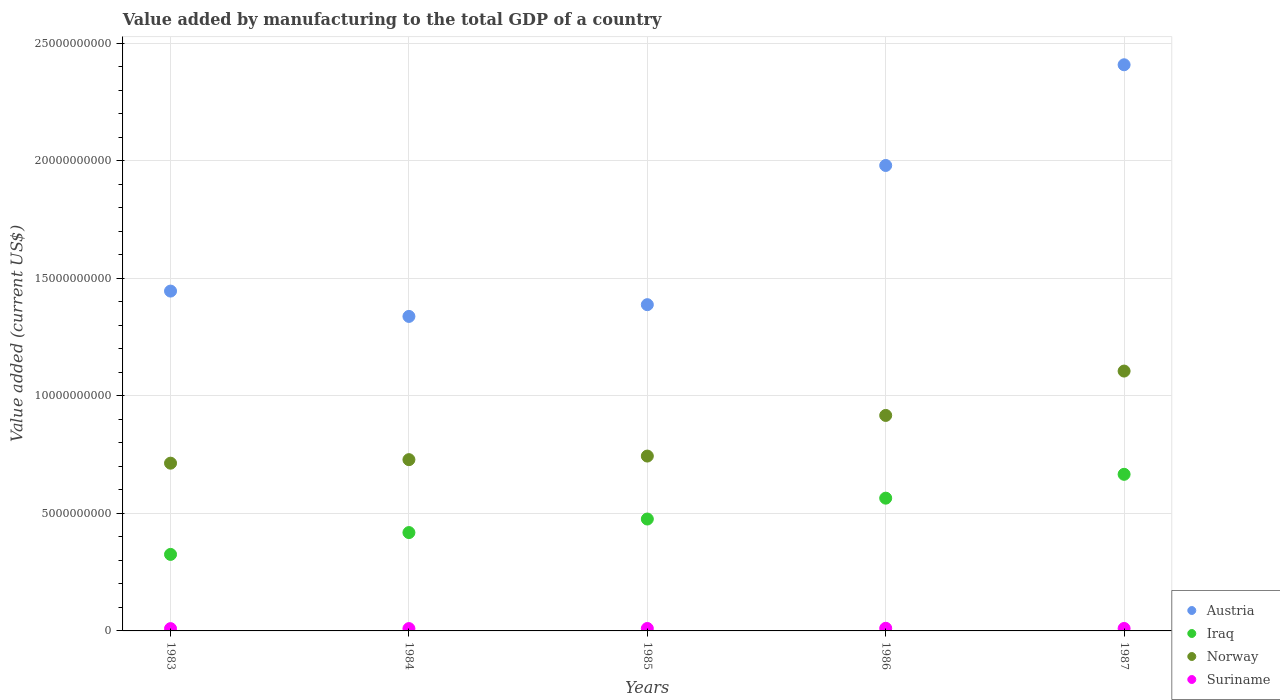How many different coloured dotlines are there?
Offer a terse response. 4. Is the number of dotlines equal to the number of legend labels?
Offer a very short reply. Yes. What is the value added by manufacturing to the total GDP in Norway in 1983?
Your response must be concise. 7.14e+09. Across all years, what is the maximum value added by manufacturing to the total GDP in Suriname?
Your answer should be very brief. 1.12e+08. Across all years, what is the minimum value added by manufacturing to the total GDP in Austria?
Provide a succinct answer. 1.34e+1. In which year was the value added by manufacturing to the total GDP in Austria maximum?
Offer a terse response. 1987. What is the total value added by manufacturing to the total GDP in Norway in the graph?
Offer a very short reply. 4.21e+1. What is the difference between the value added by manufacturing to the total GDP in Norway in 1985 and that in 1986?
Offer a terse response. -1.73e+09. What is the difference between the value added by manufacturing to the total GDP in Norway in 1985 and the value added by manufacturing to the total GDP in Iraq in 1984?
Give a very brief answer. 3.26e+09. What is the average value added by manufacturing to the total GDP in Austria per year?
Make the answer very short. 1.71e+1. In the year 1986, what is the difference between the value added by manufacturing to the total GDP in Suriname and value added by manufacturing to the total GDP in Austria?
Offer a very short reply. -1.97e+1. In how many years, is the value added by manufacturing to the total GDP in Norway greater than 12000000000 US$?
Keep it short and to the point. 0. What is the ratio of the value added by manufacturing to the total GDP in Austria in 1984 to that in 1986?
Provide a short and direct response. 0.68. Is the value added by manufacturing to the total GDP in Austria in 1984 less than that in 1987?
Give a very brief answer. Yes. What is the difference between the highest and the second highest value added by manufacturing to the total GDP in Suriname?
Your answer should be compact. 7.65e+06. What is the difference between the highest and the lowest value added by manufacturing to the total GDP in Iraq?
Your answer should be very brief. 3.41e+09. Is it the case that in every year, the sum of the value added by manufacturing to the total GDP in Norway and value added by manufacturing to the total GDP in Austria  is greater than the value added by manufacturing to the total GDP in Iraq?
Provide a succinct answer. Yes. Does the value added by manufacturing to the total GDP in Austria monotonically increase over the years?
Make the answer very short. No. Is the value added by manufacturing to the total GDP in Iraq strictly greater than the value added by manufacturing to the total GDP in Norway over the years?
Keep it short and to the point. No. Is the value added by manufacturing to the total GDP in Norway strictly less than the value added by manufacturing to the total GDP in Suriname over the years?
Make the answer very short. No. How many dotlines are there?
Your answer should be very brief. 4. How many years are there in the graph?
Your response must be concise. 5. What is the difference between two consecutive major ticks on the Y-axis?
Give a very brief answer. 5.00e+09. How many legend labels are there?
Give a very brief answer. 4. How are the legend labels stacked?
Keep it short and to the point. Vertical. What is the title of the graph?
Your answer should be very brief. Value added by manufacturing to the total GDP of a country. What is the label or title of the Y-axis?
Offer a terse response. Value added (current US$). What is the Value added (current US$) in Austria in 1983?
Ensure brevity in your answer.  1.45e+1. What is the Value added (current US$) of Iraq in 1983?
Ensure brevity in your answer.  3.26e+09. What is the Value added (current US$) of Norway in 1983?
Give a very brief answer. 7.14e+09. What is the Value added (current US$) in Suriname in 1983?
Your answer should be very brief. 9.76e+07. What is the Value added (current US$) in Austria in 1984?
Provide a short and direct response. 1.34e+1. What is the Value added (current US$) of Iraq in 1984?
Provide a short and direct response. 4.18e+09. What is the Value added (current US$) of Norway in 1984?
Offer a terse response. 7.29e+09. What is the Value added (current US$) in Suriname in 1984?
Ensure brevity in your answer.  9.87e+07. What is the Value added (current US$) of Austria in 1985?
Keep it short and to the point. 1.39e+1. What is the Value added (current US$) in Iraq in 1985?
Offer a terse response. 4.76e+09. What is the Value added (current US$) in Norway in 1985?
Ensure brevity in your answer.  7.44e+09. What is the Value added (current US$) in Suriname in 1985?
Keep it short and to the point. 1.03e+08. What is the Value added (current US$) in Austria in 1986?
Offer a very short reply. 1.98e+1. What is the Value added (current US$) of Iraq in 1986?
Your answer should be very brief. 5.65e+09. What is the Value added (current US$) of Norway in 1986?
Keep it short and to the point. 9.17e+09. What is the Value added (current US$) in Suriname in 1986?
Make the answer very short. 1.12e+08. What is the Value added (current US$) in Austria in 1987?
Offer a very short reply. 2.41e+1. What is the Value added (current US$) in Iraq in 1987?
Provide a short and direct response. 6.66e+09. What is the Value added (current US$) of Norway in 1987?
Give a very brief answer. 1.11e+1. What is the Value added (current US$) in Suriname in 1987?
Make the answer very short. 1.04e+08. Across all years, what is the maximum Value added (current US$) in Austria?
Offer a very short reply. 2.41e+1. Across all years, what is the maximum Value added (current US$) of Iraq?
Offer a terse response. 6.66e+09. Across all years, what is the maximum Value added (current US$) in Norway?
Your answer should be very brief. 1.11e+1. Across all years, what is the maximum Value added (current US$) in Suriname?
Your response must be concise. 1.12e+08. Across all years, what is the minimum Value added (current US$) of Austria?
Keep it short and to the point. 1.34e+1. Across all years, what is the minimum Value added (current US$) in Iraq?
Ensure brevity in your answer.  3.26e+09. Across all years, what is the minimum Value added (current US$) of Norway?
Your response must be concise. 7.14e+09. Across all years, what is the minimum Value added (current US$) in Suriname?
Give a very brief answer. 9.76e+07. What is the total Value added (current US$) of Austria in the graph?
Your response must be concise. 8.56e+1. What is the total Value added (current US$) of Iraq in the graph?
Your answer should be compact. 2.45e+1. What is the total Value added (current US$) of Norway in the graph?
Ensure brevity in your answer.  4.21e+1. What is the total Value added (current US$) in Suriname in the graph?
Make the answer very short. 5.16e+08. What is the difference between the Value added (current US$) of Austria in 1983 and that in 1984?
Offer a terse response. 1.08e+09. What is the difference between the Value added (current US$) in Iraq in 1983 and that in 1984?
Offer a terse response. -9.29e+08. What is the difference between the Value added (current US$) in Norway in 1983 and that in 1984?
Give a very brief answer. -1.50e+08. What is the difference between the Value added (current US$) of Suriname in 1983 and that in 1984?
Keep it short and to the point. -1.05e+06. What is the difference between the Value added (current US$) in Austria in 1983 and that in 1985?
Offer a terse response. 5.78e+08. What is the difference between the Value added (current US$) of Iraq in 1983 and that in 1985?
Your answer should be compact. -1.51e+09. What is the difference between the Value added (current US$) in Norway in 1983 and that in 1985?
Offer a very short reply. -3.03e+08. What is the difference between the Value added (current US$) of Suriname in 1983 and that in 1985?
Your answer should be very brief. -5.65e+06. What is the difference between the Value added (current US$) of Austria in 1983 and that in 1986?
Offer a very short reply. -5.34e+09. What is the difference between the Value added (current US$) of Iraq in 1983 and that in 1986?
Your answer should be compact. -2.39e+09. What is the difference between the Value added (current US$) in Norway in 1983 and that in 1986?
Give a very brief answer. -2.03e+09. What is the difference between the Value added (current US$) in Suriname in 1983 and that in 1986?
Your response must be concise. -1.44e+07. What is the difference between the Value added (current US$) in Austria in 1983 and that in 1987?
Provide a short and direct response. -9.63e+09. What is the difference between the Value added (current US$) of Iraq in 1983 and that in 1987?
Provide a short and direct response. -3.41e+09. What is the difference between the Value added (current US$) in Norway in 1983 and that in 1987?
Offer a very short reply. -3.92e+09. What is the difference between the Value added (current US$) in Suriname in 1983 and that in 1987?
Provide a succinct answer. -6.70e+06. What is the difference between the Value added (current US$) in Austria in 1984 and that in 1985?
Your answer should be compact. -5.00e+08. What is the difference between the Value added (current US$) in Iraq in 1984 and that in 1985?
Your response must be concise. -5.76e+08. What is the difference between the Value added (current US$) of Norway in 1984 and that in 1985?
Provide a succinct answer. -1.53e+08. What is the difference between the Value added (current US$) of Suriname in 1984 and that in 1985?
Ensure brevity in your answer.  -4.60e+06. What is the difference between the Value added (current US$) in Austria in 1984 and that in 1986?
Your answer should be compact. -6.42e+09. What is the difference between the Value added (current US$) of Iraq in 1984 and that in 1986?
Make the answer very short. -1.46e+09. What is the difference between the Value added (current US$) of Norway in 1984 and that in 1986?
Offer a very short reply. -1.88e+09. What is the difference between the Value added (current US$) of Suriname in 1984 and that in 1986?
Offer a terse response. -1.33e+07. What is the difference between the Value added (current US$) in Austria in 1984 and that in 1987?
Offer a very short reply. -1.07e+1. What is the difference between the Value added (current US$) of Iraq in 1984 and that in 1987?
Your answer should be compact. -2.48e+09. What is the difference between the Value added (current US$) of Norway in 1984 and that in 1987?
Provide a short and direct response. -3.77e+09. What is the difference between the Value added (current US$) of Suriname in 1984 and that in 1987?
Give a very brief answer. -5.65e+06. What is the difference between the Value added (current US$) in Austria in 1985 and that in 1986?
Give a very brief answer. -5.92e+09. What is the difference between the Value added (current US$) of Iraq in 1985 and that in 1986?
Make the answer very short. -8.88e+08. What is the difference between the Value added (current US$) of Norway in 1985 and that in 1986?
Give a very brief answer. -1.73e+09. What is the difference between the Value added (current US$) in Suriname in 1985 and that in 1986?
Keep it short and to the point. -8.70e+06. What is the difference between the Value added (current US$) in Austria in 1985 and that in 1987?
Your answer should be compact. -1.02e+1. What is the difference between the Value added (current US$) of Iraq in 1985 and that in 1987?
Your answer should be compact. -1.90e+09. What is the difference between the Value added (current US$) in Norway in 1985 and that in 1987?
Ensure brevity in your answer.  -3.62e+09. What is the difference between the Value added (current US$) of Suriname in 1985 and that in 1987?
Your response must be concise. -1.05e+06. What is the difference between the Value added (current US$) in Austria in 1986 and that in 1987?
Your answer should be compact. -4.28e+09. What is the difference between the Value added (current US$) of Iraq in 1986 and that in 1987?
Offer a very short reply. -1.01e+09. What is the difference between the Value added (current US$) in Norway in 1986 and that in 1987?
Provide a succinct answer. -1.89e+09. What is the difference between the Value added (current US$) in Suriname in 1986 and that in 1987?
Ensure brevity in your answer.  7.65e+06. What is the difference between the Value added (current US$) of Austria in 1983 and the Value added (current US$) of Iraq in 1984?
Your response must be concise. 1.03e+1. What is the difference between the Value added (current US$) of Austria in 1983 and the Value added (current US$) of Norway in 1984?
Keep it short and to the point. 7.17e+09. What is the difference between the Value added (current US$) of Austria in 1983 and the Value added (current US$) of Suriname in 1984?
Your answer should be compact. 1.44e+1. What is the difference between the Value added (current US$) of Iraq in 1983 and the Value added (current US$) of Norway in 1984?
Your response must be concise. -4.03e+09. What is the difference between the Value added (current US$) of Iraq in 1983 and the Value added (current US$) of Suriname in 1984?
Your answer should be compact. 3.16e+09. What is the difference between the Value added (current US$) in Norway in 1983 and the Value added (current US$) in Suriname in 1984?
Your answer should be very brief. 7.04e+09. What is the difference between the Value added (current US$) in Austria in 1983 and the Value added (current US$) in Iraq in 1985?
Make the answer very short. 9.70e+09. What is the difference between the Value added (current US$) of Austria in 1983 and the Value added (current US$) of Norway in 1985?
Offer a very short reply. 7.02e+09. What is the difference between the Value added (current US$) of Austria in 1983 and the Value added (current US$) of Suriname in 1985?
Ensure brevity in your answer.  1.44e+1. What is the difference between the Value added (current US$) in Iraq in 1983 and the Value added (current US$) in Norway in 1985?
Your answer should be very brief. -4.18e+09. What is the difference between the Value added (current US$) of Iraq in 1983 and the Value added (current US$) of Suriname in 1985?
Your answer should be very brief. 3.15e+09. What is the difference between the Value added (current US$) in Norway in 1983 and the Value added (current US$) in Suriname in 1985?
Offer a terse response. 7.03e+09. What is the difference between the Value added (current US$) in Austria in 1983 and the Value added (current US$) in Iraq in 1986?
Offer a terse response. 8.81e+09. What is the difference between the Value added (current US$) of Austria in 1983 and the Value added (current US$) of Norway in 1986?
Your answer should be compact. 5.29e+09. What is the difference between the Value added (current US$) in Austria in 1983 and the Value added (current US$) in Suriname in 1986?
Your answer should be compact. 1.43e+1. What is the difference between the Value added (current US$) of Iraq in 1983 and the Value added (current US$) of Norway in 1986?
Your answer should be compact. -5.91e+09. What is the difference between the Value added (current US$) of Iraq in 1983 and the Value added (current US$) of Suriname in 1986?
Keep it short and to the point. 3.14e+09. What is the difference between the Value added (current US$) in Norway in 1983 and the Value added (current US$) in Suriname in 1986?
Keep it short and to the point. 7.02e+09. What is the difference between the Value added (current US$) in Austria in 1983 and the Value added (current US$) in Iraq in 1987?
Provide a short and direct response. 7.80e+09. What is the difference between the Value added (current US$) of Austria in 1983 and the Value added (current US$) of Norway in 1987?
Provide a succinct answer. 3.40e+09. What is the difference between the Value added (current US$) of Austria in 1983 and the Value added (current US$) of Suriname in 1987?
Provide a succinct answer. 1.44e+1. What is the difference between the Value added (current US$) of Iraq in 1983 and the Value added (current US$) of Norway in 1987?
Provide a succinct answer. -7.80e+09. What is the difference between the Value added (current US$) in Iraq in 1983 and the Value added (current US$) in Suriname in 1987?
Give a very brief answer. 3.15e+09. What is the difference between the Value added (current US$) in Norway in 1983 and the Value added (current US$) in Suriname in 1987?
Give a very brief answer. 7.03e+09. What is the difference between the Value added (current US$) of Austria in 1984 and the Value added (current US$) of Iraq in 1985?
Offer a very short reply. 8.62e+09. What is the difference between the Value added (current US$) of Austria in 1984 and the Value added (current US$) of Norway in 1985?
Your answer should be compact. 5.94e+09. What is the difference between the Value added (current US$) of Austria in 1984 and the Value added (current US$) of Suriname in 1985?
Your response must be concise. 1.33e+1. What is the difference between the Value added (current US$) of Iraq in 1984 and the Value added (current US$) of Norway in 1985?
Your response must be concise. -3.26e+09. What is the difference between the Value added (current US$) in Iraq in 1984 and the Value added (current US$) in Suriname in 1985?
Ensure brevity in your answer.  4.08e+09. What is the difference between the Value added (current US$) in Norway in 1984 and the Value added (current US$) in Suriname in 1985?
Your response must be concise. 7.18e+09. What is the difference between the Value added (current US$) in Austria in 1984 and the Value added (current US$) in Iraq in 1986?
Keep it short and to the point. 7.73e+09. What is the difference between the Value added (current US$) of Austria in 1984 and the Value added (current US$) of Norway in 1986?
Ensure brevity in your answer.  4.21e+09. What is the difference between the Value added (current US$) of Austria in 1984 and the Value added (current US$) of Suriname in 1986?
Ensure brevity in your answer.  1.33e+1. What is the difference between the Value added (current US$) in Iraq in 1984 and the Value added (current US$) in Norway in 1986?
Your response must be concise. -4.98e+09. What is the difference between the Value added (current US$) in Iraq in 1984 and the Value added (current US$) in Suriname in 1986?
Your response must be concise. 4.07e+09. What is the difference between the Value added (current US$) in Norway in 1984 and the Value added (current US$) in Suriname in 1986?
Offer a terse response. 7.17e+09. What is the difference between the Value added (current US$) of Austria in 1984 and the Value added (current US$) of Iraq in 1987?
Ensure brevity in your answer.  6.72e+09. What is the difference between the Value added (current US$) in Austria in 1984 and the Value added (current US$) in Norway in 1987?
Your answer should be very brief. 2.33e+09. What is the difference between the Value added (current US$) in Austria in 1984 and the Value added (current US$) in Suriname in 1987?
Provide a succinct answer. 1.33e+1. What is the difference between the Value added (current US$) in Iraq in 1984 and the Value added (current US$) in Norway in 1987?
Your answer should be very brief. -6.87e+09. What is the difference between the Value added (current US$) of Iraq in 1984 and the Value added (current US$) of Suriname in 1987?
Offer a terse response. 4.08e+09. What is the difference between the Value added (current US$) of Norway in 1984 and the Value added (current US$) of Suriname in 1987?
Provide a succinct answer. 7.18e+09. What is the difference between the Value added (current US$) in Austria in 1985 and the Value added (current US$) in Iraq in 1986?
Offer a very short reply. 8.23e+09. What is the difference between the Value added (current US$) of Austria in 1985 and the Value added (current US$) of Norway in 1986?
Offer a very short reply. 4.71e+09. What is the difference between the Value added (current US$) in Austria in 1985 and the Value added (current US$) in Suriname in 1986?
Keep it short and to the point. 1.38e+1. What is the difference between the Value added (current US$) in Iraq in 1985 and the Value added (current US$) in Norway in 1986?
Ensure brevity in your answer.  -4.41e+09. What is the difference between the Value added (current US$) in Iraq in 1985 and the Value added (current US$) in Suriname in 1986?
Keep it short and to the point. 4.65e+09. What is the difference between the Value added (current US$) of Norway in 1985 and the Value added (current US$) of Suriname in 1986?
Provide a short and direct response. 7.33e+09. What is the difference between the Value added (current US$) in Austria in 1985 and the Value added (current US$) in Iraq in 1987?
Offer a very short reply. 7.22e+09. What is the difference between the Value added (current US$) in Austria in 1985 and the Value added (current US$) in Norway in 1987?
Keep it short and to the point. 2.82e+09. What is the difference between the Value added (current US$) in Austria in 1985 and the Value added (current US$) in Suriname in 1987?
Your answer should be compact. 1.38e+1. What is the difference between the Value added (current US$) in Iraq in 1985 and the Value added (current US$) in Norway in 1987?
Provide a short and direct response. -6.29e+09. What is the difference between the Value added (current US$) of Iraq in 1985 and the Value added (current US$) of Suriname in 1987?
Ensure brevity in your answer.  4.66e+09. What is the difference between the Value added (current US$) of Norway in 1985 and the Value added (current US$) of Suriname in 1987?
Your response must be concise. 7.33e+09. What is the difference between the Value added (current US$) in Austria in 1986 and the Value added (current US$) in Iraq in 1987?
Ensure brevity in your answer.  1.31e+1. What is the difference between the Value added (current US$) of Austria in 1986 and the Value added (current US$) of Norway in 1987?
Ensure brevity in your answer.  8.75e+09. What is the difference between the Value added (current US$) in Austria in 1986 and the Value added (current US$) in Suriname in 1987?
Ensure brevity in your answer.  1.97e+1. What is the difference between the Value added (current US$) in Iraq in 1986 and the Value added (current US$) in Norway in 1987?
Provide a short and direct response. -5.41e+09. What is the difference between the Value added (current US$) of Iraq in 1986 and the Value added (current US$) of Suriname in 1987?
Your answer should be compact. 5.54e+09. What is the difference between the Value added (current US$) in Norway in 1986 and the Value added (current US$) in Suriname in 1987?
Give a very brief answer. 9.06e+09. What is the average Value added (current US$) in Austria per year?
Offer a terse response. 1.71e+1. What is the average Value added (current US$) of Iraq per year?
Your answer should be very brief. 4.90e+09. What is the average Value added (current US$) in Norway per year?
Provide a short and direct response. 8.42e+09. What is the average Value added (current US$) in Suriname per year?
Offer a very short reply. 1.03e+08. In the year 1983, what is the difference between the Value added (current US$) in Austria and Value added (current US$) in Iraq?
Make the answer very short. 1.12e+1. In the year 1983, what is the difference between the Value added (current US$) of Austria and Value added (current US$) of Norway?
Make the answer very short. 7.32e+09. In the year 1983, what is the difference between the Value added (current US$) of Austria and Value added (current US$) of Suriname?
Offer a terse response. 1.44e+1. In the year 1983, what is the difference between the Value added (current US$) in Iraq and Value added (current US$) in Norway?
Offer a terse response. -3.88e+09. In the year 1983, what is the difference between the Value added (current US$) in Iraq and Value added (current US$) in Suriname?
Your answer should be compact. 3.16e+09. In the year 1983, what is the difference between the Value added (current US$) of Norway and Value added (current US$) of Suriname?
Your answer should be compact. 7.04e+09. In the year 1984, what is the difference between the Value added (current US$) in Austria and Value added (current US$) in Iraq?
Keep it short and to the point. 9.20e+09. In the year 1984, what is the difference between the Value added (current US$) in Austria and Value added (current US$) in Norway?
Your response must be concise. 6.09e+09. In the year 1984, what is the difference between the Value added (current US$) in Austria and Value added (current US$) in Suriname?
Your answer should be compact. 1.33e+1. In the year 1984, what is the difference between the Value added (current US$) in Iraq and Value added (current US$) in Norway?
Offer a terse response. -3.10e+09. In the year 1984, what is the difference between the Value added (current US$) in Iraq and Value added (current US$) in Suriname?
Make the answer very short. 4.09e+09. In the year 1984, what is the difference between the Value added (current US$) of Norway and Value added (current US$) of Suriname?
Your response must be concise. 7.19e+09. In the year 1985, what is the difference between the Value added (current US$) of Austria and Value added (current US$) of Iraq?
Your response must be concise. 9.12e+09. In the year 1985, what is the difference between the Value added (current US$) of Austria and Value added (current US$) of Norway?
Your response must be concise. 6.44e+09. In the year 1985, what is the difference between the Value added (current US$) in Austria and Value added (current US$) in Suriname?
Offer a very short reply. 1.38e+1. In the year 1985, what is the difference between the Value added (current US$) in Iraq and Value added (current US$) in Norway?
Offer a terse response. -2.68e+09. In the year 1985, what is the difference between the Value added (current US$) of Iraq and Value added (current US$) of Suriname?
Your response must be concise. 4.66e+09. In the year 1985, what is the difference between the Value added (current US$) of Norway and Value added (current US$) of Suriname?
Give a very brief answer. 7.34e+09. In the year 1986, what is the difference between the Value added (current US$) of Austria and Value added (current US$) of Iraq?
Give a very brief answer. 1.42e+1. In the year 1986, what is the difference between the Value added (current US$) in Austria and Value added (current US$) in Norway?
Offer a terse response. 1.06e+1. In the year 1986, what is the difference between the Value added (current US$) in Austria and Value added (current US$) in Suriname?
Offer a very short reply. 1.97e+1. In the year 1986, what is the difference between the Value added (current US$) of Iraq and Value added (current US$) of Norway?
Keep it short and to the point. -3.52e+09. In the year 1986, what is the difference between the Value added (current US$) of Iraq and Value added (current US$) of Suriname?
Make the answer very short. 5.54e+09. In the year 1986, what is the difference between the Value added (current US$) of Norway and Value added (current US$) of Suriname?
Your answer should be very brief. 9.06e+09. In the year 1987, what is the difference between the Value added (current US$) in Austria and Value added (current US$) in Iraq?
Your response must be concise. 1.74e+1. In the year 1987, what is the difference between the Value added (current US$) of Austria and Value added (current US$) of Norway?
Provide a succinct answer. 1.30e+1. In the year 1987, what is the difference between the Value added (current US$) of Austria and Value added (current US$) of Suriname?
Offer a very short reply. 2.40e+1. In the year 1987, what is the difference between the Value added (current US$) of Iraq and Value added (current US$) of Norway?
Give a very brief answer. -4.39e+09. In the year 1987, what is the difference between the Value added (current US$) in Iraq and Value added (current US$) in Suriname?
Keep it short and to the point. 6.56e+09. In the year 1987, what is the difference between the Value added (current US$) of Norway and Value added (current US$) of Suriname?
Ensure brevity in your answer.  1.10e+1. What is the ratio of the Value added (current US$) of Austria in 1983 to that in 1984?
Your response must be concise. 1.08. What is the ratio of the Value added (current US$) of Iraq in 1983 to that in 1984?
Provide a short and direct response. 0.78. What is the ratio of the Value added (current US$) in Norway in 1983 to that in 1984?
Your answer should be compact. 0.98. What is the ratio of the Value added (current US$) in Suriname in 1983 to that in 1984?
Make the answer very short. 0.99. What is the ratio of the Value added (current US$) of Austria in 1983 to that in 1985?
Your response must be concise. 1.04. What is the ratio of the Value added (current US$) of Iraq in 1983 to that in 1985?
Make the answer very short. 0.68. What is the ratio of the Value added (current US$) in Norway in 1983 to that in 1985?
Keep it short and to the point. 0.96. What is the ratio of the Value added (current US$) in Suriname in 1983 to that in 1985?
Your answer should be very brief. 0.95. What is the ratio of the Value added (current US$) in Austria in 1983 to that in 1986?
Offer a terse response. 0.73. What is the ratio of the Value added (current US$) of Iraq in 1983 to that in 1986?
Your answer should be compact. 0.58. What is the ratio of the Value added (current US$) of Norway in 1983 to that in 1986?
Offer a terse response. 0.78. What is the ratio of the Value added (current US$) of Suriname in 1983 to that in 1986?
Your answer should be very brief. 0.87. What is the ratio of the Value added (current US$) of Austria in 1983 to that in 1987?
Give a very brief answer. 0.6. What is the ratio of the Value added (current US$) in Iraq in 1983 to that in 1987?
Offer a terse response. 0.49. What is the ratio of the Value added (current US$) of Norway in 1983 to that in 1987?
Provide a succinct answer. 0.65. What is the ratio of the Value added (current US$) of Suriname in 1983 to that in 1987?
Your answer should be very brief. 0.94. What is the ratio of the Value added (current US$) in Austria in 1984 to that in 1985?
Provide a succinct answer. 0.96. What is the ratio of the Value added (current US$) in Iraq in 1984 to that in 1985?
Ensure brevity in your answer.  0.88. What is the ratio of the Value added (current US$) in Norway in 1984 to that in 1985?
Your answer should be very brief. 0.98. What is the ratio of the Value added (current US$) of Suriname in 1984 to that in 1985?
Your answer should be compact. 0.96. What is the ratio of the Value added (current US$) in Austria in 1984 to that in 1986?
Your response must be concise. 0.68. What is the ratio of the Value added (current US$) of Iraq in 1984 to that in 1986?
Your response must be concise. 0.74. What is the ratio of the Value added (current US$) in Norway in 1984 to that in 1986?
Your answer should be very brief. 0.79. What is the ratio of the Value added (current US$) of Suriname in 1984 to that in 1986?
Your answer should be very brief. 0.88. What is the ratio of the Value added (current US$) of Austria in 1984 to that in 1987?
Your response must be concise. 0.56. What is the ratio of the Value added (current US$) in Iraq in 1984 to that in 1987?
Your answer should be compact. 0.63. What is the ratio of the Value added (current US$) in Norway in 1984 to that in 1987?
Provide a succinct answer. 0.66. What is the ratio of the Value added (current US$) in Suriname in 1984 to that in 1987?
Offer a terse response. 0.95. What is the ratio of the Value added (current US$) in Austria in 1985 to that in 1986?
Make the answer very short. 0.7. What is the ratio of the Value added (current US$) of Iraq in 1985 to that in 1986?
Provide a succinct answer. 0.84. What is the ratio of the Value added (current US$) of Norway in 1985 to that in 1986?
Make the answer very short. 0.81. What is the ratio of the Value added (current US$) in Suriname in 1985 to that in 1986?
Provide a short and direct response. 0.92. What is the ratio of the Value added (current US$) in Austria in 1985 to that in 1987?
Your answer should be very brief. 0.58. What is the ratio of the Value added (current US$) in Iraq in 1985 to that in 1987?
Provide a short and direct response. 0.71. What is the ratio of the Value added (current US$) in Norway in 1985 to that in 1987?
Provide a short and direct response. 0.67. What is the ratio of the Value added (current US$) of Suriname in 1985 to that in 1987?
Your answer should be compact. 0.99. What is the ratio of the Value added (current US$) of Austria in 1986 to that in 1987?
Give a very brief answer. 0.82. What is the ratio of the Value added (current US$) of Iraq in 1986 to that in 1987?
Ensure brevity in your answer.  0.85. What is the ratio of the Value added (current US$) of Norway in 1986 to that in 1987?
Your answer should be very brief. 0.83. What is the ratio of the Value added (current US$) in Suriname in 1986 to that in 1987?
Offer a terse response. 1.07. What is the difference between the highest and the second highest Value added (current US$) of Austria?
Provide a short and direct response. 4.28e+09. What is the difference between the highest and the second highest Value added (current US$) of Iraq?
Your answer should be compact. 1.01e+09. What is the difference between the highest and the second highest Value added (current US$) of Norway?
Offer a very short reply. 1.89e+09. What is the difference between the highest and the second highest Value added (current US$) of Suriname?
Offer a very short reply. 7.65e+06. What is the difference between the highest and the lowest Value added (current US$) in Austria?
Give a very brief answer. 1.07e+1. What is the difference between the highest and the lowest Value added (current US$) in Iraq?
Offer a very short reply. 3.41e+09. What is the difference between the highest and the lowest Value added (current US$) in Norway?
Offer a very short reply. 3.92e+09. What is the difference between the highest and the lowest Value added (current US$) of Suriname?
Give a very brief answer. 1.44e+07. 